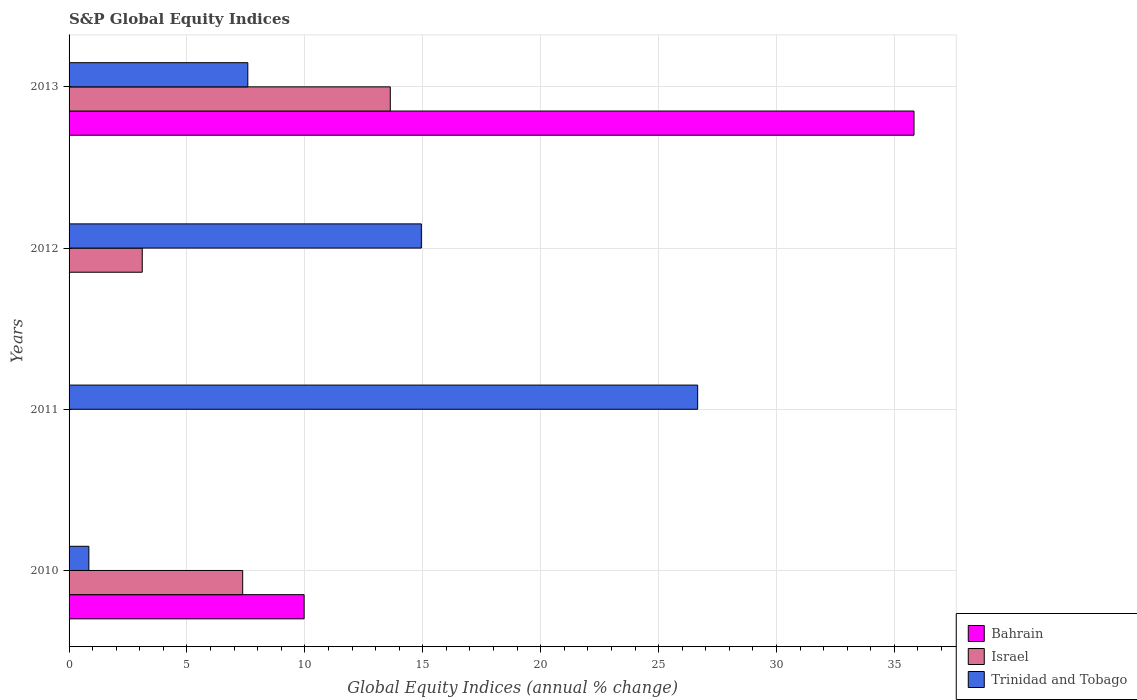How many bars are there on the 1st tick from the top?
Your answer should be very brief. 3. How many bars are there on the 4th tick from the bottom?
Your response must be concise. 3. In how many cases, is the number of bars for a given year not equal to the number of legend labels?
Your answer should be very brief. 2. What is the global equity indices in Trinidad and Tobago in 2011?
Provide a succinct answer. 26.66. Across all years, what is the maximum global equity indices in Israel?
Offer a terse response. 13.62. Across all years, what is the minimum global equity indices in Israel?
Offer a terse response. 0. In which year was the global equity indices in Bahrain maximum?
Offer a terse response. 2013. What is the total global equity indices in Bahrain in the graph?
Keep it short and to the point. 45.8. What is the difference between the global equity indices in Trinidad and Tobago in 2012 and that in 2013?
Keep it short and to the point. 7.36. What is the difference between the global equity indices in Israel in 2010 and the global equity indices in Bahrain in 2013?
Make the answer very short. -28.47. What is the average global equity indices in Trinidad and Tobago per year?
Provide a short and direct response. 12.5. In the year 2013, what is the difference between the global equity indices in Trinidad and Tobago and global equity indices in Israel?
Offer a very short reply. -6.04. In how many years, is the global equity indices in Trinidad and Tobago greater than 11 %?
Give a very brief answer. 2. What is the ratio of the global equity indices in Trinidad and Tobago in 2010 to that in 2012?
Offer a very short reply. 0.06. Is the global equity indices in Trinidad and Tobago in 2010 less than that in 2012?
Ensure brevity in your answer.  Yes. Is the difference between the global equity indices in Trinidad and Tobago in 2012 and 2013 greater than the difference between the global equity indices in Israel in 2012 and 2013?
Your answer should be compact. Yes. What is the difference between the highest and the second highest global equity indices in Israel?
Your answer should be compact. 6.26. What is the difference between the highest and the lowest global equity indices in Israel?
Make the answer very short. 13.62. Is the sum of the global equity indices in Trinidad and Tobago in 2011 and 2013 greater than the maximum global equity indices in Bahrain across all years?
Offer a very short reply. No. Is it the case that in every year, the sum of the global equity indices in Bahrain and global equity indices in Israel is greater than the global equity indices in Trinidad and Tobago?
Provide a short and direct response. No. Are all the bars in the graph horizontal?
Offer a terse response. Yes. How many years are there in the graph?
Your response must be concise. 4. Are the values on the major ticks of X-axis written in scientific E-notation?
Your response must be concise. No. Does the graph contain any zero values?
Your answer should be very brief. Yes. Where does the legend appear in the graph?
Your response must be concise. Bottom right. What is the title of the graph?
Your answer should be very brief. S&P Global Equity Indices. Does "Lower middle income" appear as one of the legend labels in the graph?
Make the answer very short. No. What is the label or title of the X-axis?
Ensure brevity in your answer.  Global Equity Indices (annual % change). What is the label or title of the Y-axis?
Offer a terse response. Years. What is the Global Equity Indices (annual % change) of Bahrain in 2010?
Offer a terse response. 9.97. What is the Global Equity Indices (annual % change) of Israel in 2010?
Provide a short and direct response. 7.36. What is the Global Equity Indices (annual % change) of Trinidad and Tobago in 2010?
Offer a terse response. 0.84. What is the Global Equity Indices (annual % change) in Trinidad and Tobago in 2011?
Provide a short and direct response. 26.66. What is the Global Equity Indices (annual % change) in Bahrain in 2012?
Provide a succinct answer. 0. What is the Global Equity Indices (annual % change) of Israel in 2012?
Give a very brief answer. 3.1. What is the Global Equity Indices (annual % change) in Trinidad and Tobago in 2012?
Your answer should be compact. 14.94. What is the Global Equity Indices (annual % change) in Bahrain in 2013?
Keep it short and to the point. 35.83. What is the Global Equity Indices (annual % change) in Israel in 2013?
Ensure brevity in your answer.  13.62. What is the Global Equity Indices (annual % change) in Trinidad and Tobago in 2013?
Offer a very short reply. 7.58. Across all years, what is the maximum Global Equity Indices (annual % change) in Bahrain?
Provide a short and direct response. 35.83. Across all years, what is the maximum Global Equity Indices (annual % change) of Israel?
Offer a very short reply. 13.62. Across all years, what is the maximum Global Equity Indices (annual % change) of Trinidad and Tobago?
Your answer should be compact. 26.66. Across all years, what is the minimum Global Equity Indices (annual % change) in Bahrain?
Keep it short and to the point. 0. Across all years, what is the minimum Global Equity Indices (annual % change) of Trinidad and Tobago?
Make the answer very short. 0.84. What is the total Global Equity Indices (annual % change) of Bahrain in the graph?
Offer a terse response. 45.8. What is the total Global Equity Indices (annual % change) of Israel in the graph?
Your answer should be very brief. 24.09. What is the total Global Equity Indices (annual % change) in Trinidad and Tobago in the graph?
Provide a succinct answer. 50.01. What is the difference between the Global Equity Indices (annual % change) in Trinidad and Tobago in 2010 and that in 2011?
Provide a succinct answer. -25.82. What is the difference between the Global Equity Indices (annual % change) of Israel in 2010 and that in 2012?
Make the answer very short. 4.26. What is the difference between the Global Equity Indices (annual % change) in Trinidad and Tobago in 2010 and that in 2012?
Keep it short and to the point. -14.1. What is the difference between the Global Equity Indices (annual % change) in Bahrain in 2010 and that in 2013?
Your answer should be very brief. -25.86. What is the difference between the Global Equity Indices (annual % change) of Israel in 2010 and that in 2013?
Make the answer very short. -6.26. What is the difference between the Global Equity Indices (annual % change) of Trinidad and Tobago in 2010 and that in 2013?
Offer a very short reply. -6.74. What is the difference between the Global Equity Indices (annual % change) in Trinidad and Tobago in 2011 and that in 2012?
Offer a very short reply. 11.72. What is the difference between the Global Equity Indices (annual % change) in Trinidad and Tobago in 2011 and that in 2013?
Offer a very short reply. 19.08. What is the difference between the Global Equity Indices (annual % change) in Israel in 2012 and that in 2013?
Your answer should be compact. -10.52. What is the difference between the Global Equity Indices (annual % change) in Trinidad and Tobago in 2012 and that in 2013?
Offer a very short reply. 7.36. What is the difference between the Global Equity Indices (annual % change) of Bahrain in 2010 and the Global Equity Indices (annual % change) of Trinidad and Tobago in 2011?
Make the answer very short. -16.69. What is the difference between the Global Equity Indices (annual % change) of Israel in 2010 and the Global Equity Indices (annual % change) of Trinidad and Tobago in 2011?
Provide a short and direct response. -19.29. What is the difference between the Global Equity Indices (annual % change) in Bahrain in 2010 and the Global Equity Indices (annual % change) in Israel in 2012?
Your answer should be compact. 6.86. What is the difference between the Global Equity Indices (annual % change) of Bahrain in 2010 and the Global Equity Indices (annual % change) of Trinidad and Tobago in 2012?
Make the answer very short. -4.97. What is the difference between the Global Equity Indices (annual % change) in Israel in 2010 and the Global Equity Indices (annual % change) in Trinidad and Tobago in 2012?
Your answer should be very brief. -7.58. What is the difference between the Global Equity Indices (annual % change) in Bahrain in 2010 and the Global Equity Indices (annual % change) in Israel in 2013?
Keep it short and to the point. -3.65. What is the difference between the Global Equity Indices (annual % change) in Bahrain in 2010 and the Global Equity Indices (annual % change) in Trinidad and Tobago in 2013?
Your answer should be very brief. 2.39. What is the difference between the Global Equity Indices (annual % change) in Israel in 2010 and the Global Equity Indices (annual % change) in Trinidad and Tobago in 2013?
Keep it short and to the point. -0.22. What is the difference between the Global Equity Indices (annual % change) in Israel in 2012 and the Global Equity Indices (annual % change) in Trinidad and Tobago in 2013?
Provide a short and direct response. -4.48. What is the average Global Equity Indices (annual % change) of Bahrain per year?
Offer a very short reply. 11.45. What is the average Global Equity Indices (annual % change) of Israel per year?
Provide a succinct answer. 6.02. What is the average Global Equity Indices (annual % change) in Trinidad and Tobago per year?
Your answer should be very brief. 12.5. In the year 2010, what is the difference between the Global Equity Indices (annual % change) of Bahrain and Global Equity Indices (annual % change) of Israel?
Offer a very short reply. 2.61. In the year 2010, what is the difference between the Global Equity Indices (annual % change) of Bahrain and Global Equity Indices (annual % change) of Trinidad and Tobago?
Provide a succinct answer. 9.13. In the year 2010, what is the difference between the Global Equity Indices (annual % change) of Israel and Global Equity Indices (annual % change) of Trinidad and Tobago?
Ensure brevity in your answer.  6.52. In the year 2012, what is the difference between the Global Equity Indices (annual % change) of Israel and Global Equity Indices (annual % change) of Trinidad and Tobago?
Ensure brevity in your answer.  -11.84. In the year 2013, what is the difference between the Global Equity Indices (annual % change) of Bahrain and Global Equity Indices (annual % change) of Israel?
Give a very brief answer. 22.21. In the year 2013, what is the difference between the Global Equity Indices (annual % change) in Bahrain and Global Equity Indices (annual % change) in Trinidad and Tobago?
Keep it short and to the point. 28.25. In the year 2013, what is the difference between the Global Equity Indices (annual % change) in Israel and Global Equity Indices (annual % change) in Trinidad and Tobago?
Your response must be concise. 6.04. What is the ratio of the Global Equity Indices (annual % change) of Trinidad and Tobago in 2010 to that in 2011?
Offer a terse response. 0.03. What is the ratio of the Global Equity Indices (annual % change) of Israel in 2010 to that in 2012?
Your response must be concise. 2.37. What is the ratio of the Global Equity Indices (annual % change) in Trinidad and Tobago in 2010 to that in 2012?
Make the answer very short. 0.06. What is the ratio of the Global Equity Indices (annual % change) in Bahrain in 2010 to that in 2013?
Provide a short and direct response. 0.28. What is the ratio of the Global Equity Indices (annual % change) in Israel in 2010 to that in 2013?
Provide a succinct answer. 0.54. What is the ratio of the Global Equity Indices (annual % change) of Trinidad and Tobago in 2010 to that in 2013?
Your response must be concise. 0.11. What is the ratio of the Global Equity Indices (annual % change) in Trinidad and Tobago in 2011 to that in 2012?
Make the answer very short. 1.78. What is the ratio of the Global Equity Indices (annual % change) of Trinidad and Tobago in 2011 to that in 2013?
Keep it short and to the point. 3.52. What is the ratio of the Global Equity Indices (annual % change) in Israel in 2012 to that in 2013?
Your response must be concise. 0.23. What is the ratio of the Global Equity Indices (annual % change) of Trinidad and Tobago in 2012 to that in 2013?
Your answer should be very brief. 1.97. What is the difference between the highest and the second highest Global Equity Indices (annual % change) of Israel?
Your response must be concise. 6.26. What is the difference between the highest and the second highest Global Equity Indices (annual % change) in Trinidad and Tobago?
Your answer should be compact. 11.72. What is the difference between the highest and the lowest Global Equity Indices (annual % change) of Bahrain?
Make the answer very short. 35.83. What is the difference between the highest and the lowest Global Equity Indices (annual % change) of Israel?
Offer a very short reply. 13.62. What is the difference between the highest and the lowest Global Equity Indices (annual % change) of Trinidad and Tobago?
Offer a very short reply. 25.82. 